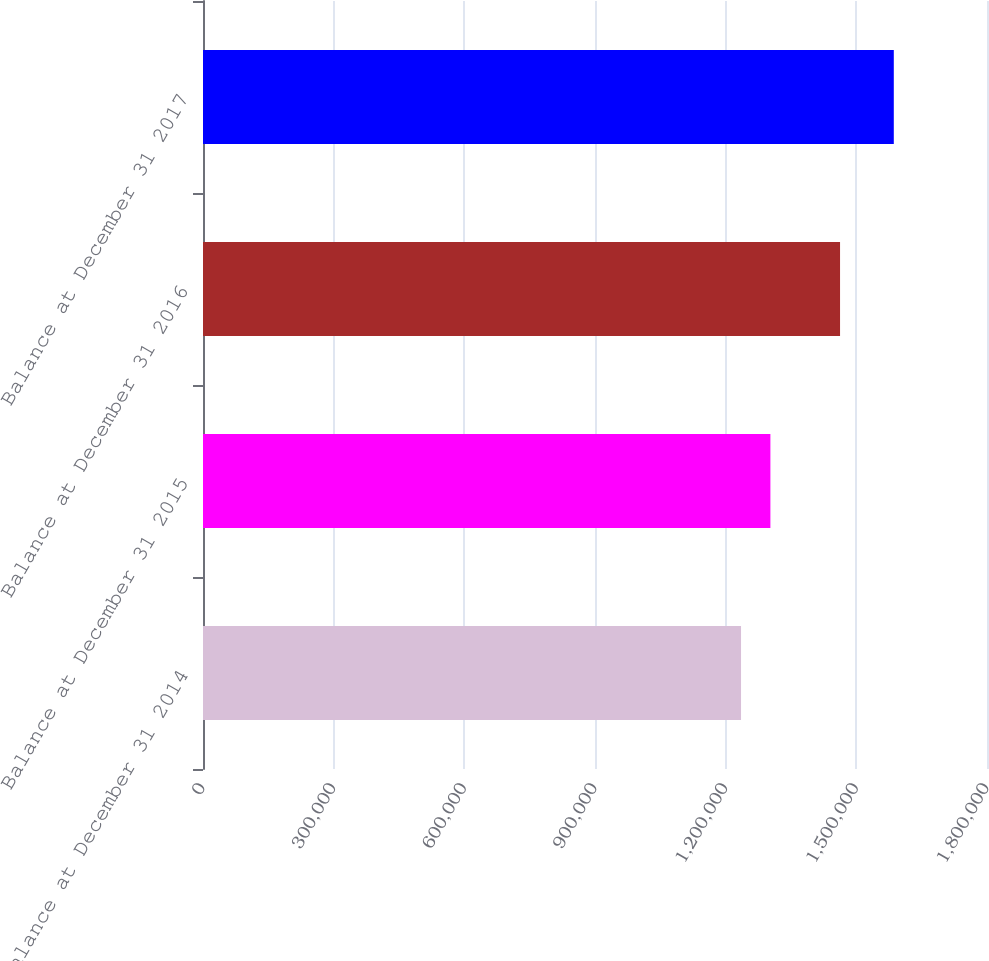Convert chart to OTSL. <chart><loc_0><loc_0><loc_500><loc_500><bar_chart><fcel>Balance at December 31 2014<fcel>Balance at December 31 2015<fcel>Balance at December 31 2016<fcel>Balance at December 31 2017<nl><fcel>1.2353e+06<fcel>1.3027e+06<fcel>1.4626e+06<fcel>1.58602e+06<nl></chart> 